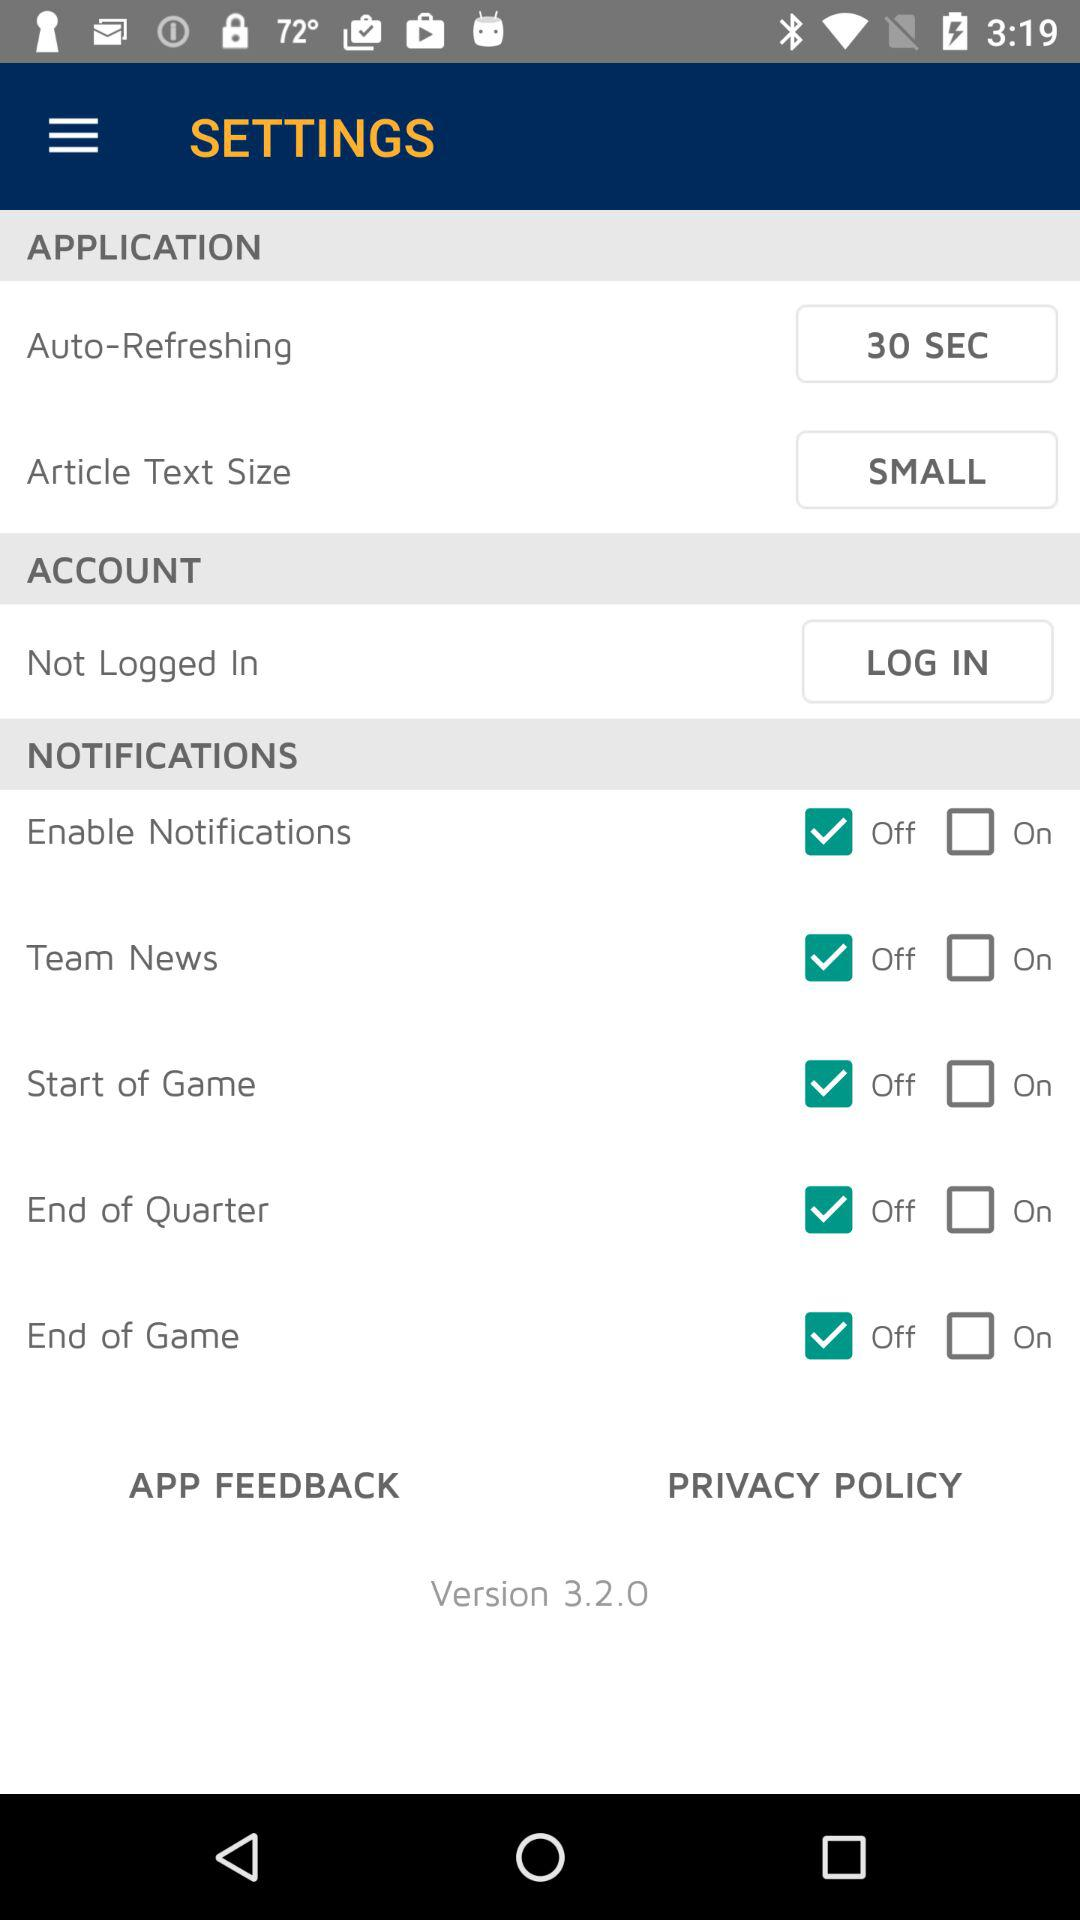Which option is in the account settings? The option in the account settings is "Not Logged In". 